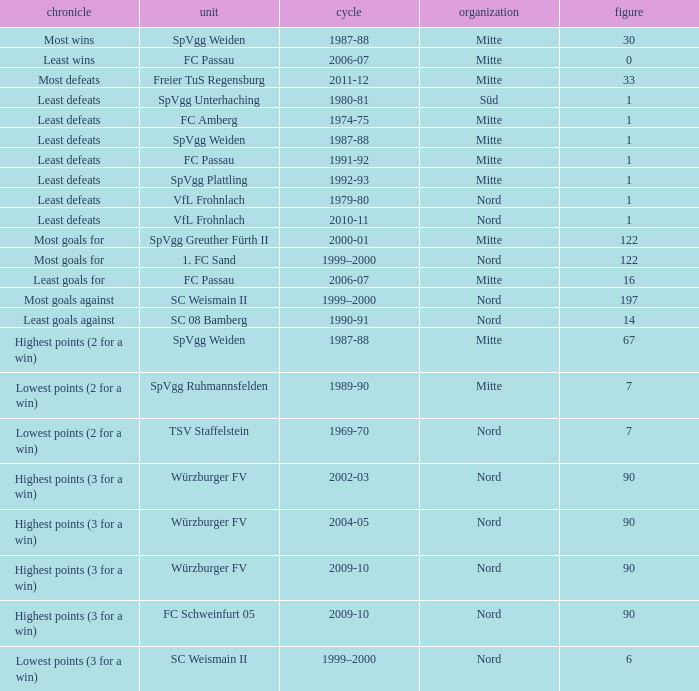What league has a number less than 1? Mitte. 